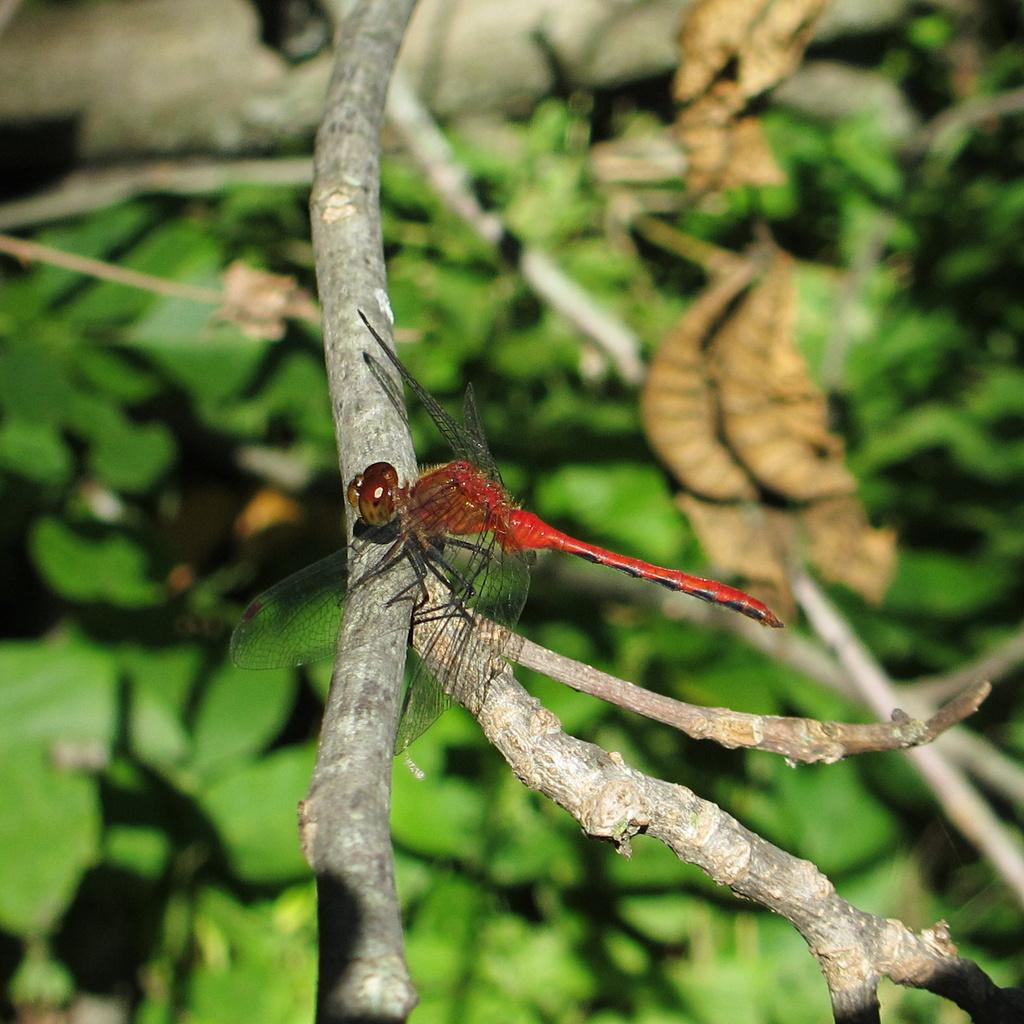What is the main subject of the image? The main subject of the image is a house fly. Where is the house fly located in the image? The house fly is on a stem. What can be seen in the background of the image? There are leaves in the background of the image. What type of property does the house fly own in the image? There is no indication in the image that the house fly owns any property. What type of flesh can be seen on the house fly in the image? There is no flesh visible on the house fly in the image, as it is an insect. 